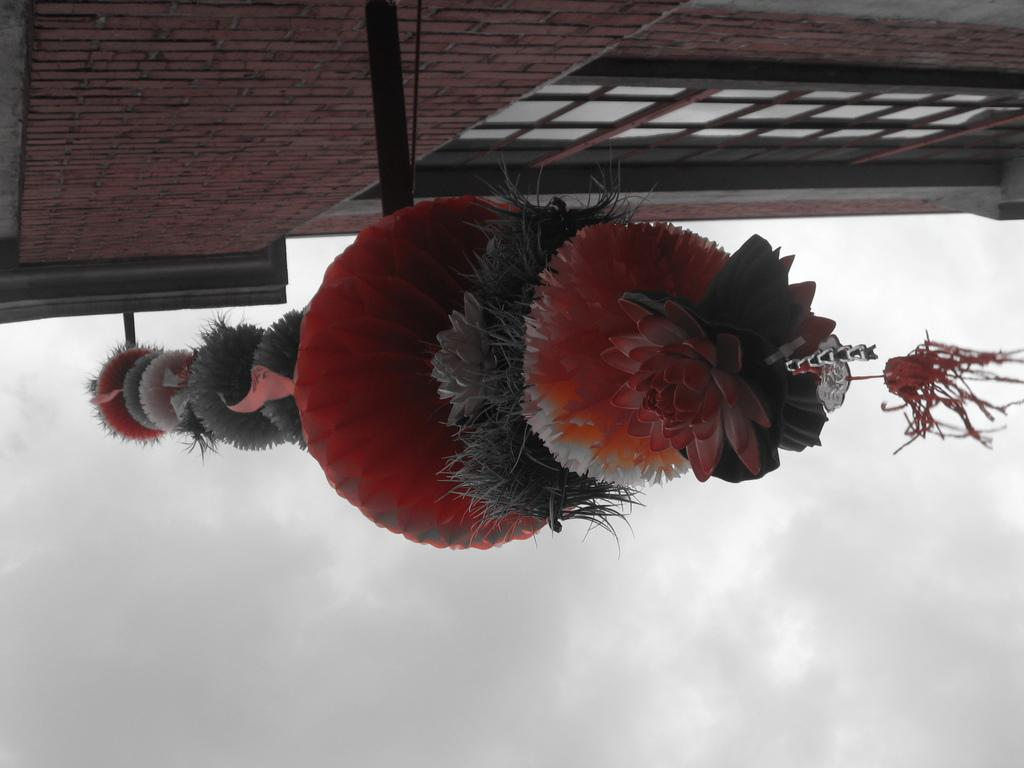What is the main subject in the middle of the image? There is a decorative item in the middle of the image. Where is the decorative item located? The decorative item is attached to a wall of a building. What can be seen on the building besides the decorative item? The building has windows. What is visible in the background of the image? There are clouds in the sky in the background of the image. What type of fiction is being read by the group in the image? There is no group or reading activity present in the image; it features a decorative item attached to a building wall. 